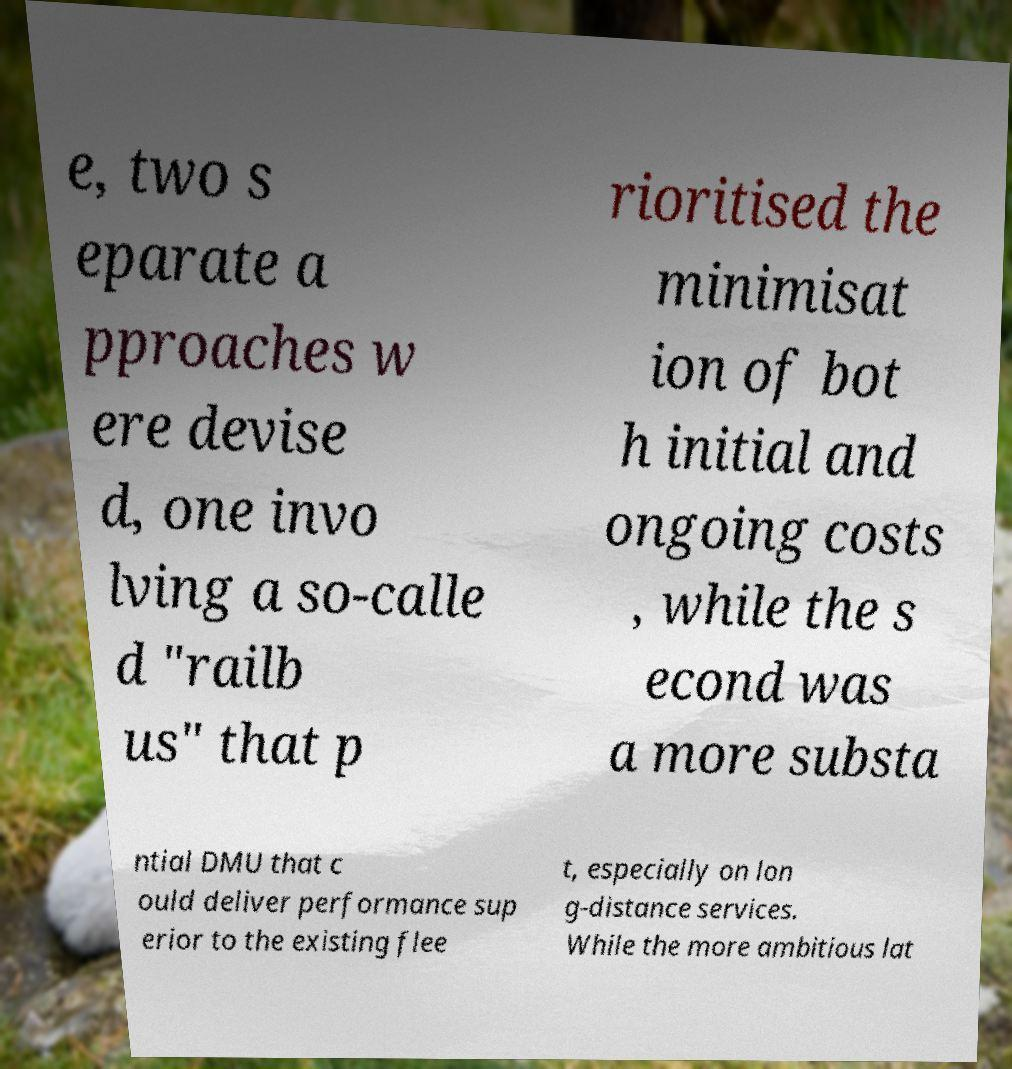Please read and relay the text visible in this image. What does it say? e, two s eparate a pproaches w ere devise d, one invo lving a so-calle d "railb us" that p rioritised the minimisat ion of bot h initial and ongoing costs , while the s econd was a more substa ntial DMU that c ould deliver performance sup erior to the existing flee t, especially on lon g-distance services. While the more ambitious lat 